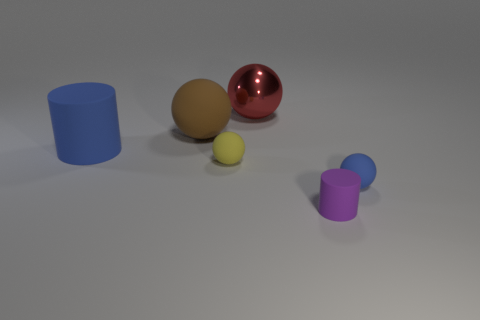Add 2 small spheres. How many objects exist? 8 Subtract all purple spheres. Subtract all green blocks. How many spheres are left? 4 Subtract all cylinders. How many objects are left? 4 Add 1 brown cylinders. How many brown cylinders exist? 1 Subtract 0 cyan cubes. How many objects are left? 6 Subtract all purple rubber cylinders. Subtract all balls. How many objects are left? 1 Add 1 purple cylinders. How many purple cylinders are left? 2 